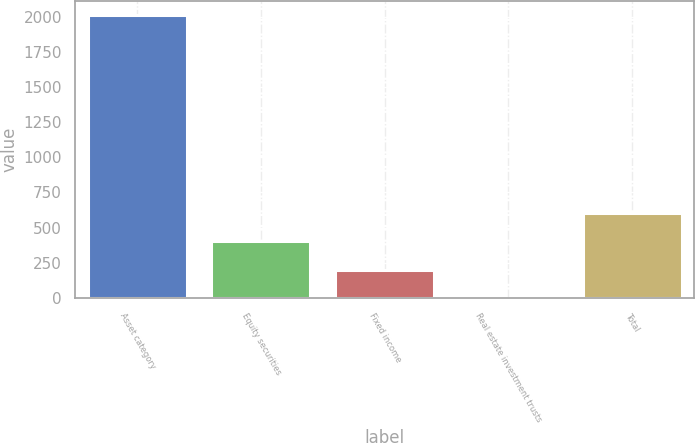Convert chart. <chart><loc_0><loc_0><loc_500><loc_500><bar_chart><fcel>Asset category<fcel>Equity securities<fcel>Fixed income<fcel>Real estate investment trusts<fcel>Total<nl><fcel>2013<fcel>403.4<fcel>202.2<fcel>1<fcel>604.6<nl></chart> 